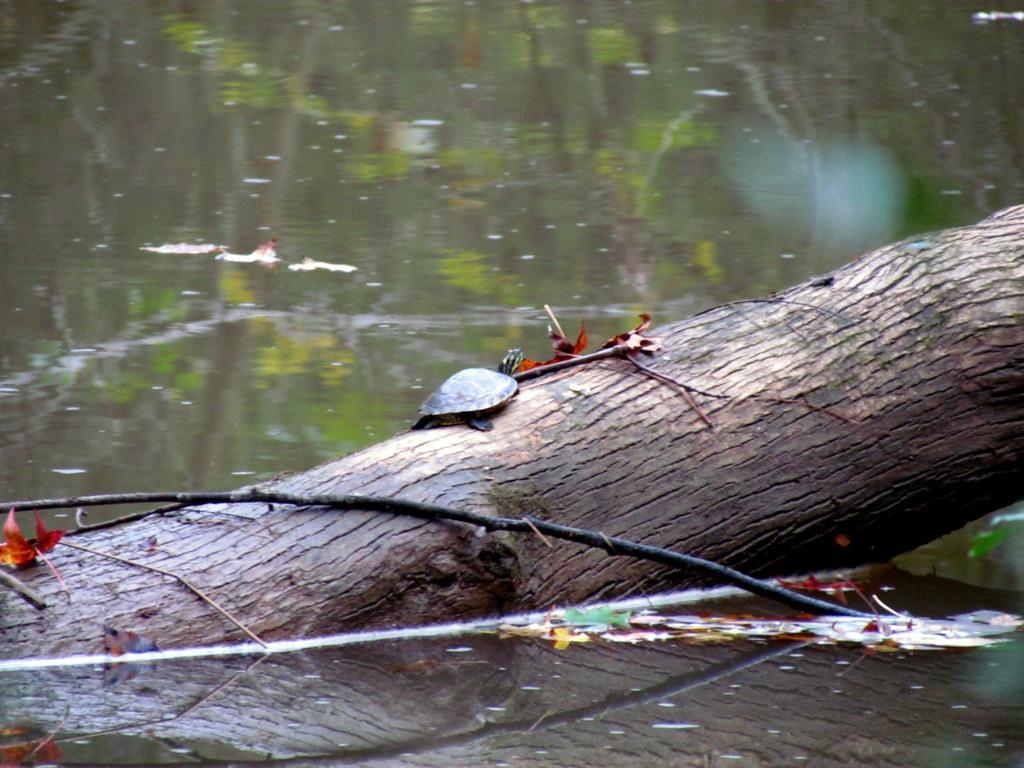Describe this image in one or two sentences. In this image we can see a wooden log and stick are partially in the water and leaves are on the water. 